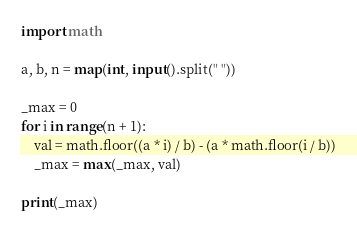Convert code to text. <code><loc_0><loc_0><loc_500><loc_500><_Python_>import math

a, b, n = map(int, input().split(" "))

_max = 0
for i in range(n + 1):
    val = math.floor((a * i) / b) - (a * math.floor(i / b))
    _max = max(_max, val)

print(_max)</code> 